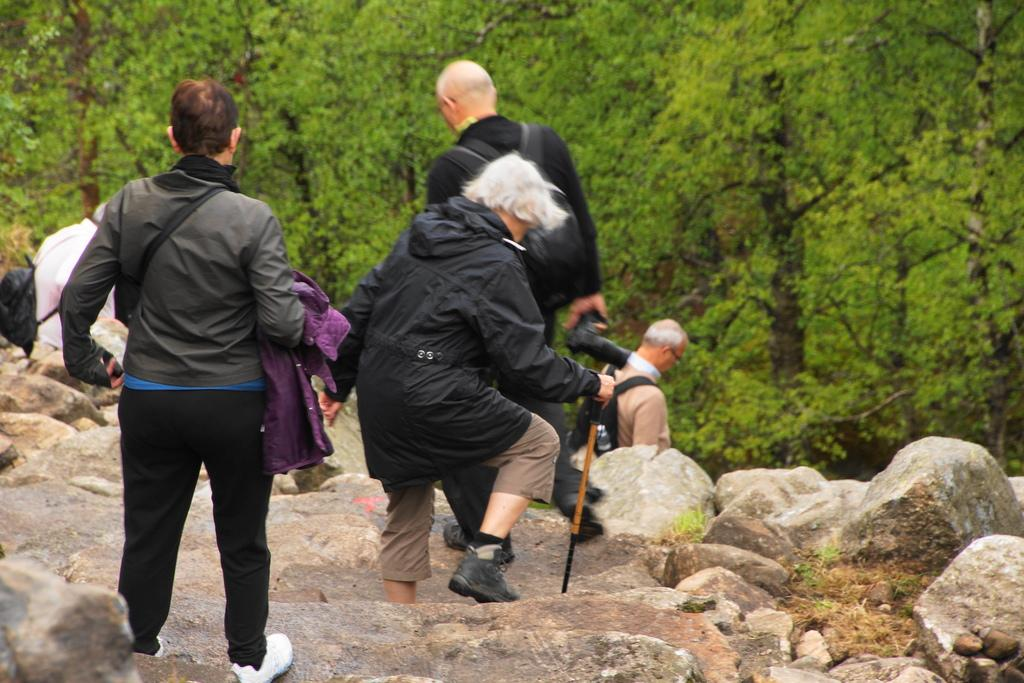What are the people in the image doing? There are many people walking in the center of the image. What can be seen in the background of the image? There are trees in the background of the image. What type of ground surface is visible at the bottom of the image? There are stones visible at the bottom of the image. What type of wire is being used to pull the carriage in the image? There is no wire or carriage present in the image; it features people walking and trees in the background. 